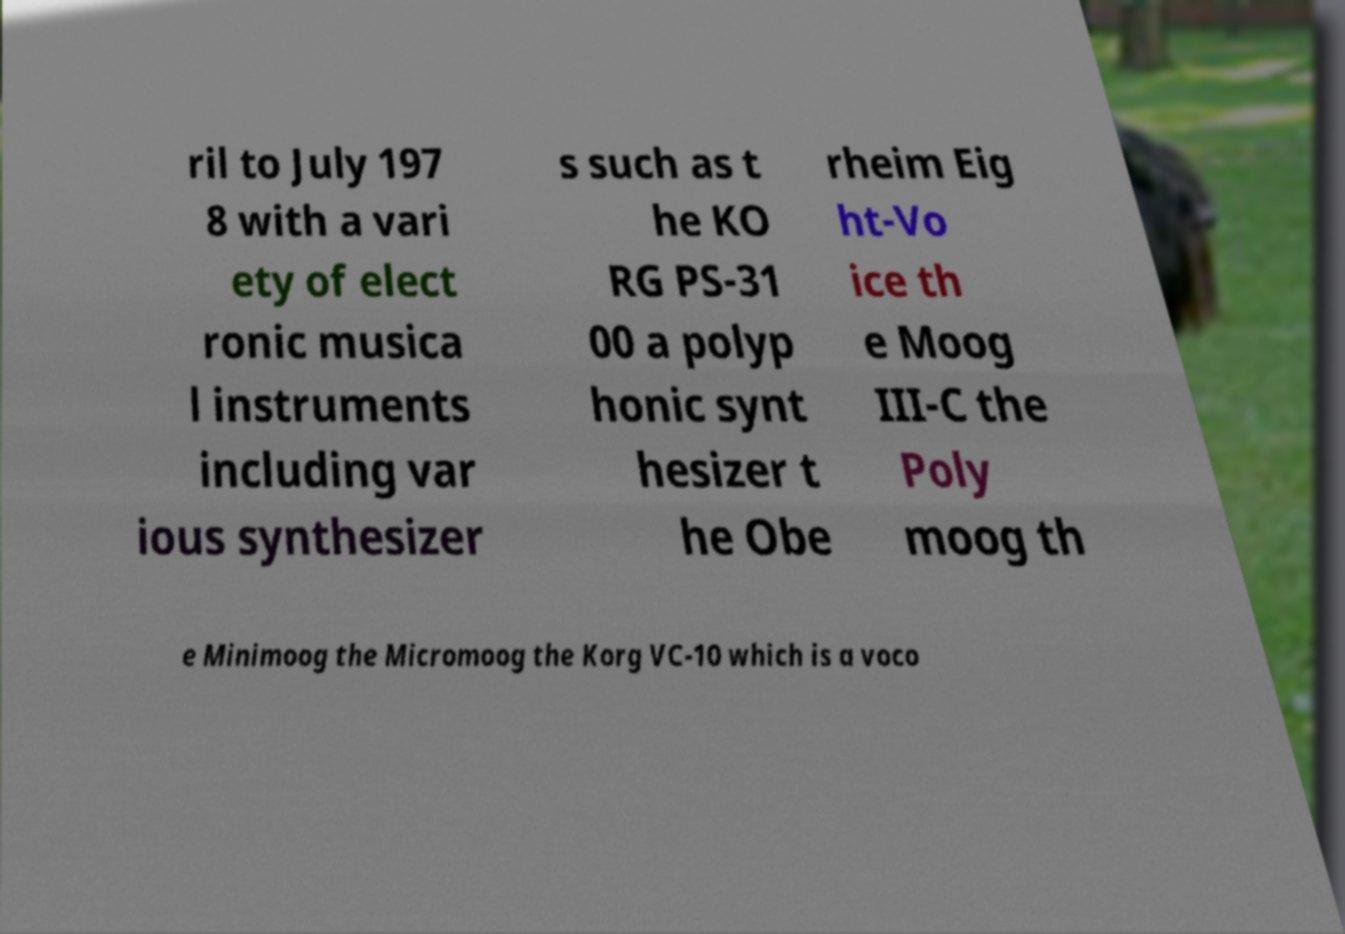I need the written content from this picture converted into text. Can you do that? ril to July 197 8 with a vari ety of elect ronic musica l instruments including var ious synthesizer s such as t he KO RG PS-31 00 a polyp honic synt hesizer t he Obe rheim Eig ht-Vo ice th e Moog III-C the Poly moog th e Minimoog the Micromoog the Korg VC-10 which is a voco 